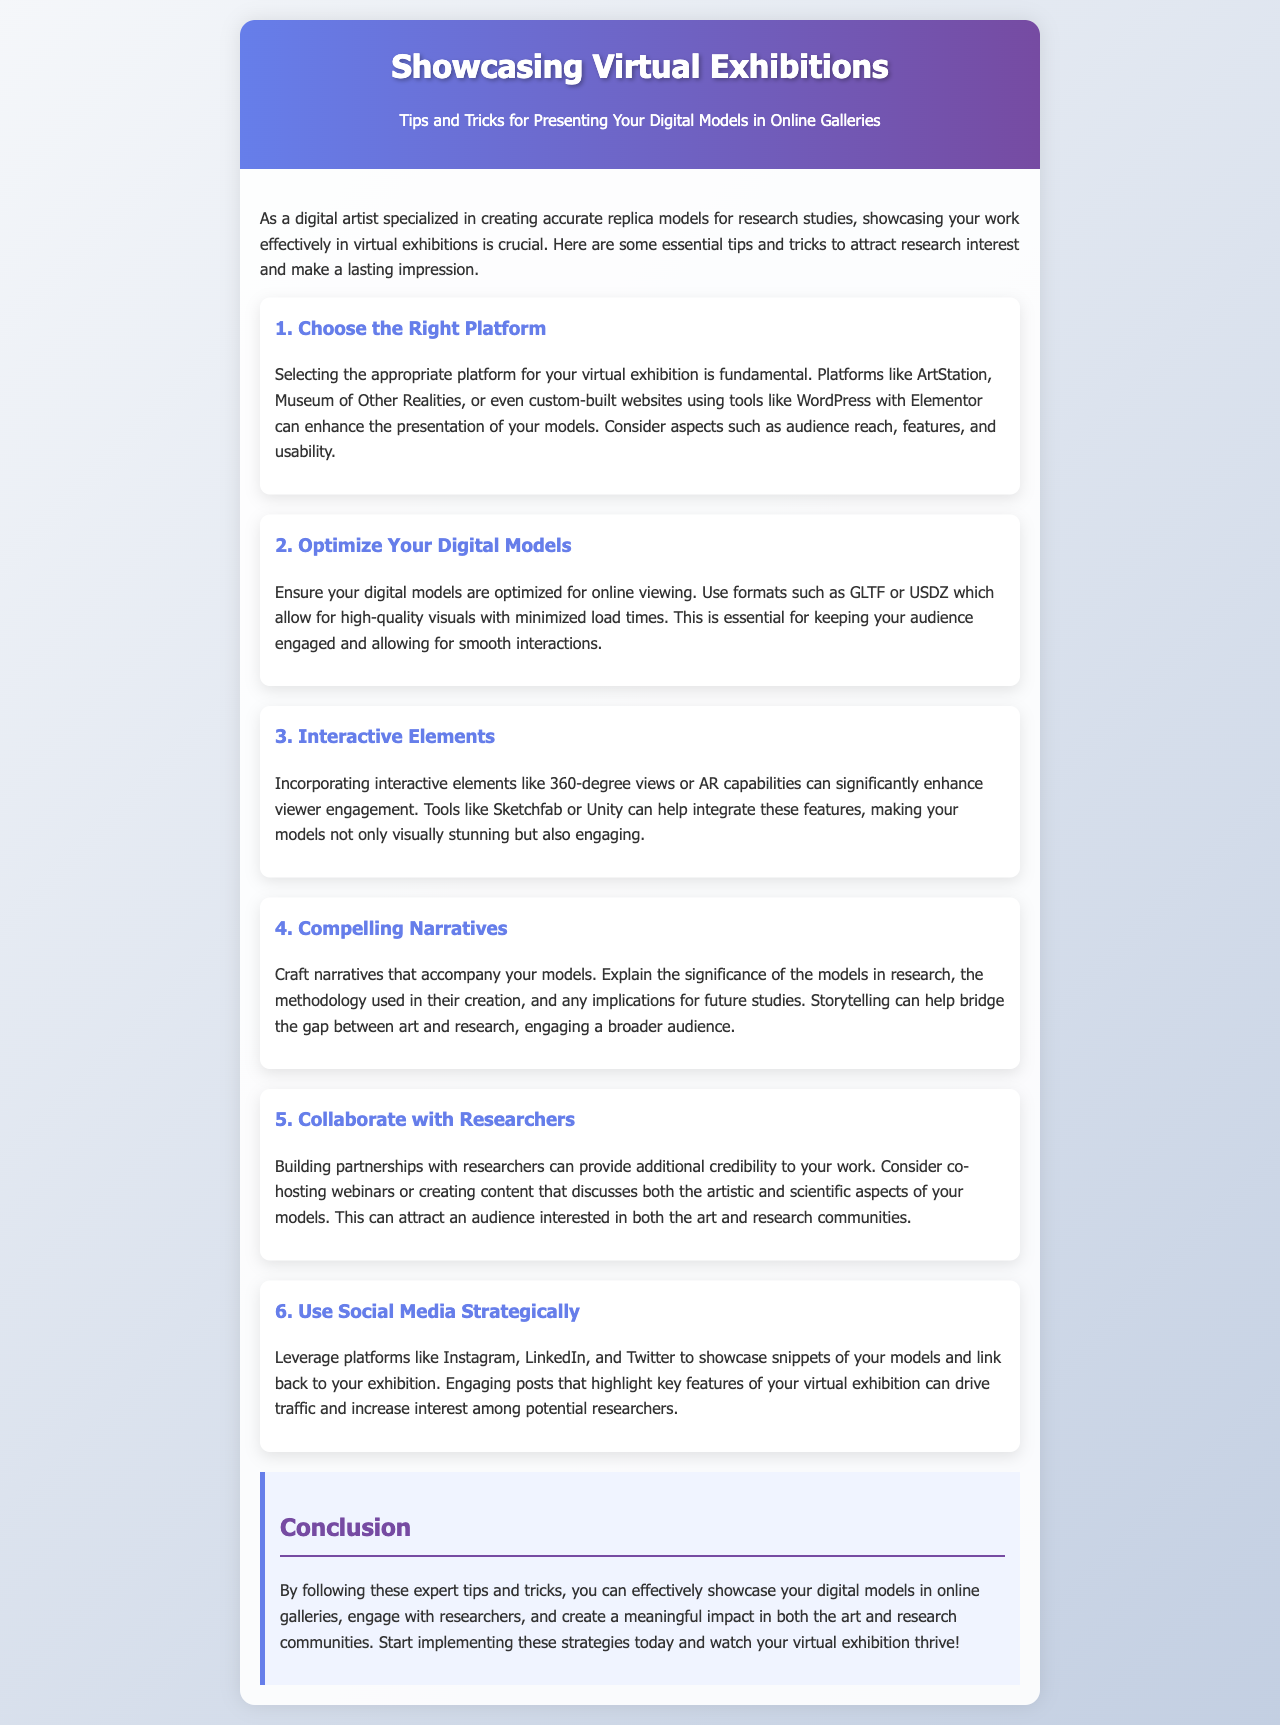what is the title of the newsletter? The title mentioned in the document is presented clearly in the header section.
Answer: Showcasing Virtual Exhibitions which platforms are mentioned as options for virtual exhibitions? The document lists several platforms that are suitable for digital exhibitions in the first tip.
Answer: ArtStation, Museum of Other Realities what type of models should you optimize for online viewing? The content specifically discusses optimizing digital models for better audience engagement.
Answer: digital models name one tool suggested for integrating interactive elements. The document mentions tools that can help with engagement features in the third tip.
Answer: Sketchfab how many tips are provided in the newsletter? The document enumerates several sections, each representing a tip, which helps in counting.
Answer: 6 what narrative aspects should accompany your models according to the document? The fourth tip emphasizes the importance of storytelling in relation to the models.
Answer: significance, methodology, implications which social media platform is mentioned for driving traffic to exhibitions? The sixth section suggests using specific platforms to showcase and promote the models.
Answer: Instagram who can provide additional credibility to digital artists? The fifth tip discusses collaborations that enhance the artist's credibility.
Answer: researchers 